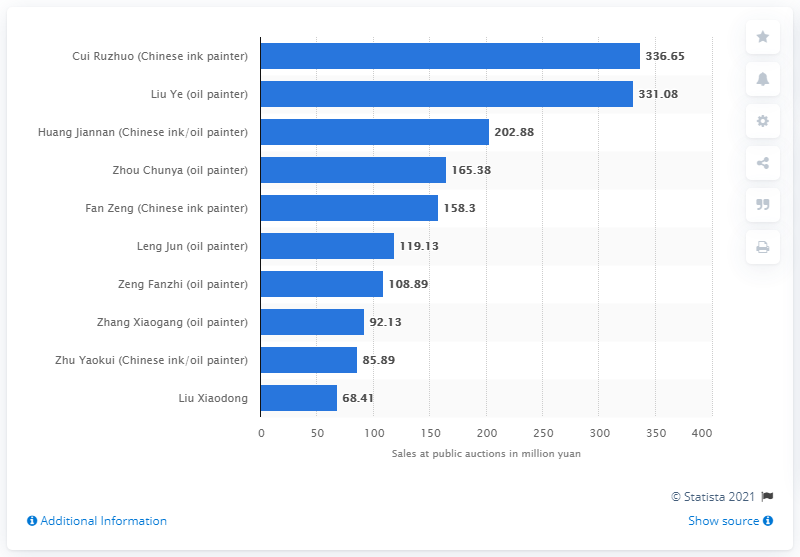Outline some significant characteristics in this image. Cui Ruzuo sold 336.65 items at public auctions in 2020, according to records. 